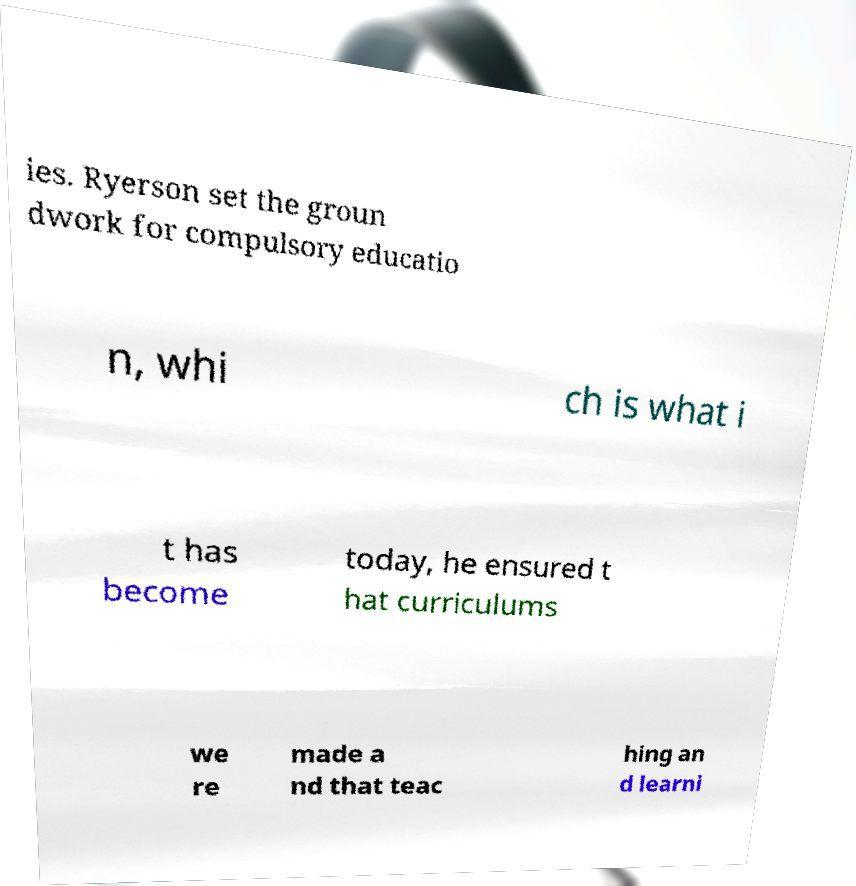Could you extract and type out the text from this image? ies. Ryerson set the groun dwork for compulsory educatio n, whi ch is what i t has become today, he ensured t hat curriculums we re made a nd that teac hing an d learni 